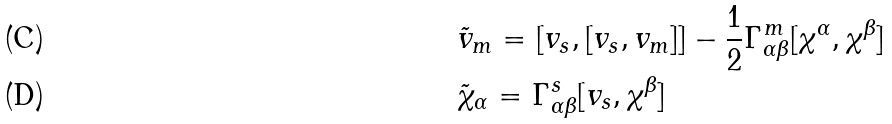<formula> <loc_0><loc_0><loc_500><loc_500>& \tilde { v } _ { m } = [ v _ { s } , [ v _ { s } , v _ { m } ] ] - \frac { 1 } { 2 } \Gamma _ { \alpha \beta } ^ { m } [ \chi ^ { \alpha } , \chi ^ { \beta } ] \\ & \tilde { \chi } _ { \alpha } = \Gamma _ { \alpha \beta } ^ { s } [ v _ { s } , \chi ^ { \beta } ]</formula> 